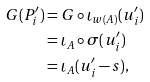Convert formula to latex. <formula><loc_0><loc_0><loc_500><loc_500>G ( P _ { i } ^ { \prime } ) & = G \circ \iota _ { w ( A ) } ( u _ { i } ^ { \prime } ) \\ & = \iota _ { A } \circ \sigma ( u _ { i } ^ { \prime } ) \\ & = \iota _ { A } ( u _ { i } ^ { \prime } - s ) ,</formula> 